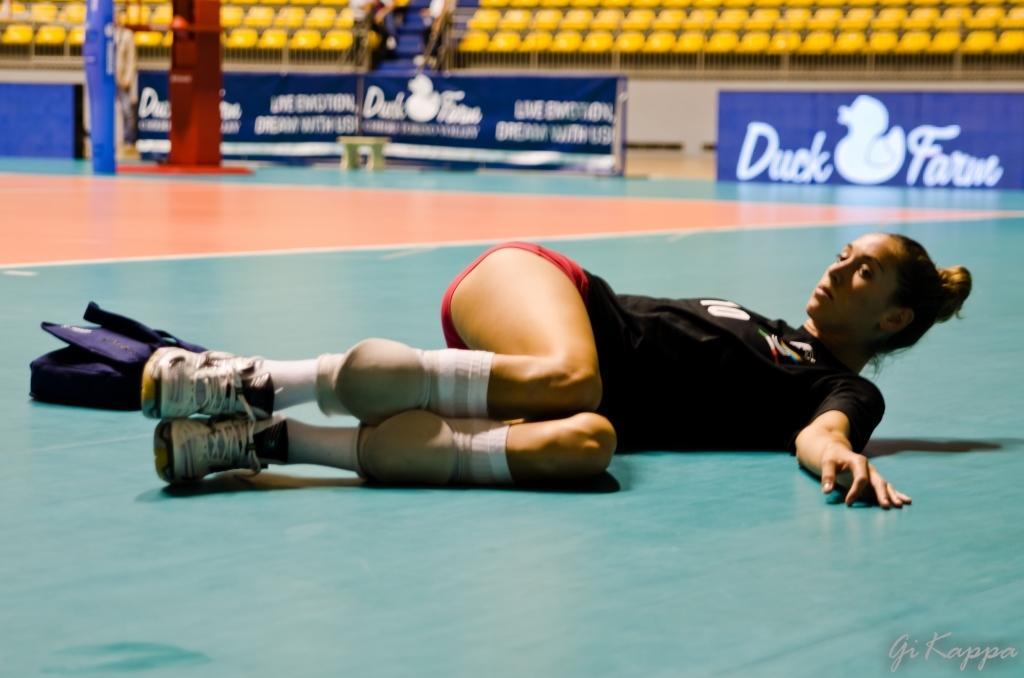Could you give a brief overview of what you see in this image? There is a woman laying on the floor and we can see bag. Background we can see chairs and hoardings. 